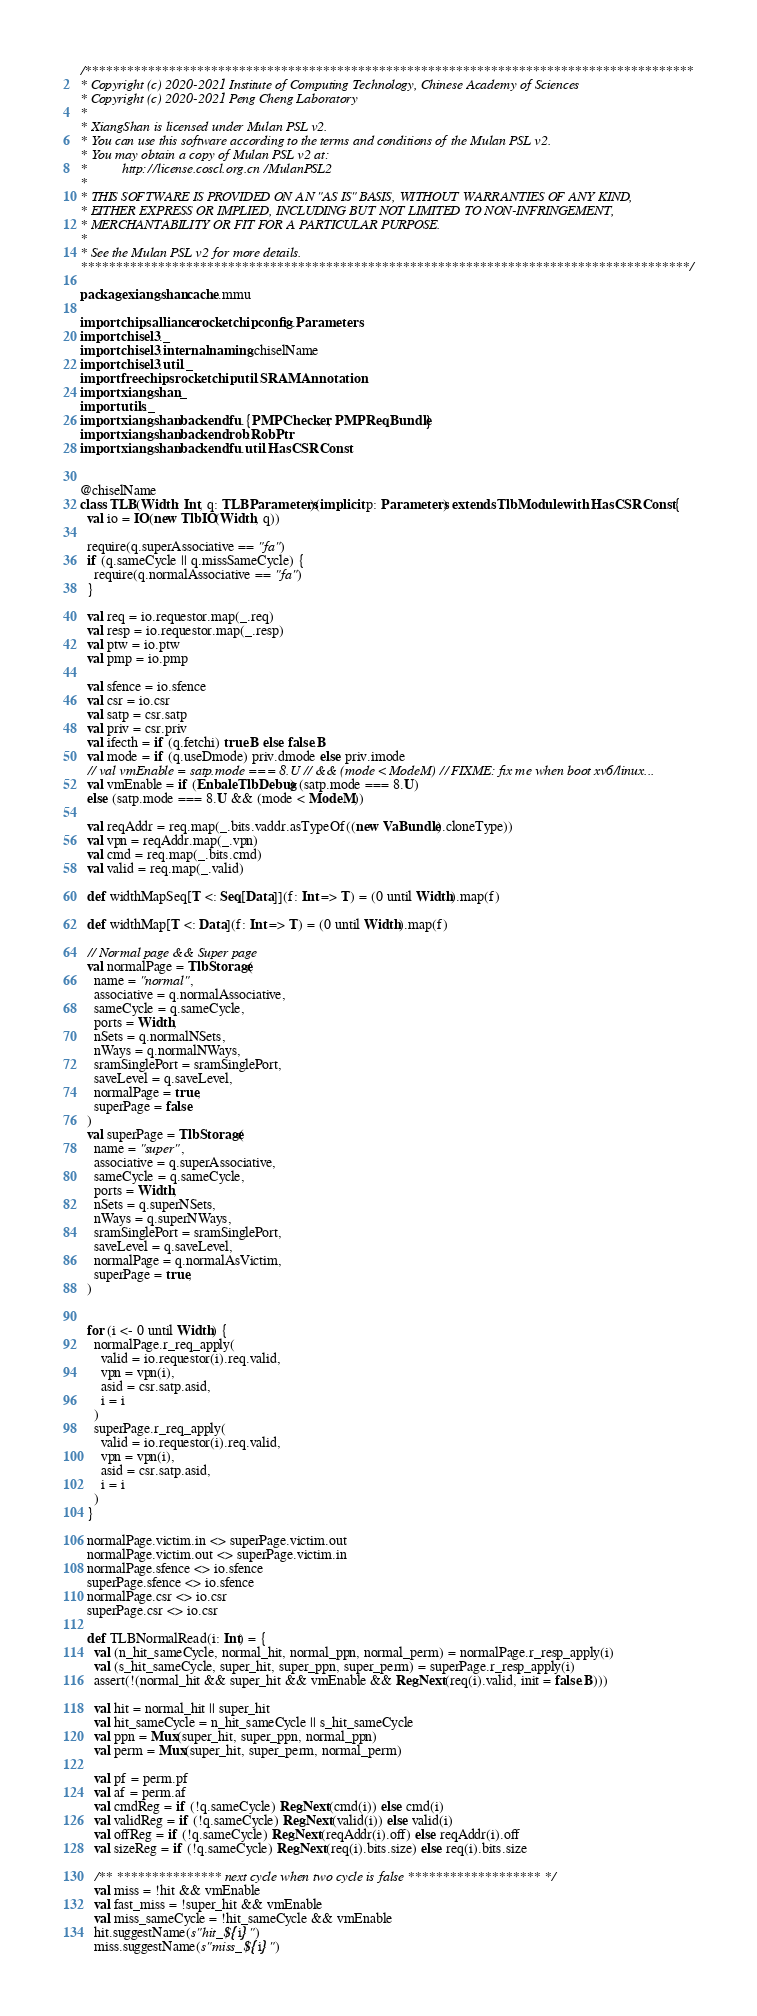Convert code to text. <code><loc_0><loc_0><loc_500><loc_500><_Scala_>/***************************************************************************************
* Copyright (c) 2020-2021 Institute of Computing Technology, Chinese Academy of Sciences
* Copyright (c) 2020-2021 Peng Cheng Laboratory
*
* XiangShan is licensed under Mulan PSL v2.
* You can use this software according to the terms and conditions of the Mulan PSL v2.
* You may obtain a copy of Mulan PSL v2 at:
*          http://license.coscl.org.cn/MulanPSL2
*
* THIS SOFTWARE IS PROVIDED ON AN "AS IS" BASIS, WITHOUT WARRANTIES OF ANY KIND,
* EITHER EXPRESS OR IMPLIED, INCLUDING BUT NOT LIMITED TO NON-INFRINGEMENT,
* MERCHANTABILITY OR FIT FOR A PARTICULAR PURPOSE.
*
* See the Mulan PSL v2 for more details.
***************************************************************************************/

package xiangshan.cache.mmu

import chipsalliance.rocketchip.config.Parameters
import chisel3._
import chisel3.internal.naming.chiselName
import chisel3.util._
import freechips.rocketchip.util.SRAMAnnotation
import xiangshan._
import utils._
import xiangshan.backend.fu.{PMPChecker, PMPReqBundle}
import xiangshan.backend.rob.RobPtr
import xiangshan.backend.fu.util.HasCSRConst


@chiselName
class TLB(Width: Int, q: TLBParameters)(implicit p: Parameters) extends TlbModule with HasCSRConst {
  val io = IO(new TlbIO(Width, q))

  require(q.superAssociative == "fa")
  if (q.sameCycle || q.missSameCycle) {
    require(q.normalAssociative == "fa")
  }

  val req = io.requestor.map(_.req)
  val resp = io.requestor.map(_.resp)
  val ptw = io.ptw
  val pmp = io.pmp

  val sfence = io.sfence
  val csr = io.csr
  val satp = csr.satp
  val priv = csr.priv
  val ifecth = if (q.fetchi) true.B else false.B
  val mode = if (q.useDmode) priv.dmode else priv.imode
  // val vmEnable = satp.mode === 8.U // && (mode < ModeM) // FIXME: fix me when boot xv6/linux...
  val vmEnable = if (EnbaleTlbDebug) (satp.mode === 8.U)
  else (satp.mode === 8.U && (mode < ModeM))

  val reqAddr = req.map(_.bits.vaddr.asTypeOf((new VaBundle).cloneType))
  val vpn = reqAddr.map(_.vpn)
  val cmd = req.map(_.bits.cmd)
  val valid = req.map(_.valid)

  def widthMapSeq[T <: Seq[Data]](f: Int => T) = (0 until Width).map(f)

  def widthMap[T <: Data](f: Int => T) = (0 until Width).map(f)

  // Normal page && Super page
  val normalPage = TlbStorage(
    name = "normal",
    associative = q.normalAssociative,
    sameCycle = q.sameCycle,
    ports = Width,
    nSets = q.normalNSets,
    nWays = q.normalNWays,
    sramSinglePort = sramSinglePort,
    saveLevel = q.saveLevel,
    normalPage = true,
    superPage = false
  )
  val superPage = TlbStorage(
    name = "super",
    associative = q.superAssociative,
    sameCycle = q.sameCycle,
    ports = Width,
    nSets = q.superNSets,
    nWays = q.superNWays,
    sramSinglePort = sramSinglePort,
    saveLevel = q.saveLevel,
    normalPage = q.normalAsVictim,
    superPage = true,
  )


  for (i <- 0 until Width) {
    normalPage.r_req_apply(
      valid = io.requestor(i).req.valid,
      vpn = vpn(i),
      asid = csr.satp.asid,
      i = i
    )
    superPage.r_req_apply(
      valid = io.requestor(i).req.valid,
      vpn = vpn(i),
      asid = csr.satp.asid,
      i = i
    )
  }

  normalPage.victim.in <> superPage.victim.out
  normalPage.victim.out <> superPage.victim.in
  normalPage.sfence <> io.sfence
  superPage.sfence <> io.sfence
  normalPage.csr <> io.csr
  superPage.csr <> io.csr

  def TLBNormalRead(i: Int) = {
    val (n_hit_sameCycle, normal_hit, normal_ppn, normal_perm) = normalPage.r_resp_apply(i)
    val (s_hit_sameCycle, super_hit, super_ppn, super_perm) = superPage.r_resp_apply(i)
    assert(!(normal_hit && super_hit && vmEnable && RegNext(req(i).valid, init = false.B)))

    val hit = normal_hit || super_hit
    val hit_sameCycle = n_hit_sameCycle || s_hit_sameCycle
    val ppn = Mux(super_hit, super_ppn, normal_ppn)
    val perm = Mux(super_hit, super_perm, normal_perm)

    val pf = perm.pf
    val af = perm.af
    val cmdReg = if (!q.sameCycle) RegNext(cmd(i)) else cmd(i)
    val validReg = if (!q.sameCycle) RegNext(valid(i)) else valid(i)
    val offReg = if (!q.sameCycle) RegNext(reqAddr(i).off) else reqAddr(i).off
    val sizeReg = if (!q.sameCycle) RegNext(req(i).bits.size) else req(i).bits.size

    /** *************** next cycle when two cycle is false******************* */
    val miss = !hit && vmEnable
    val fast_miss = !super_hit && vmEnable
    val miss_sameCycle = !hit_sameCycle && vmEnable
    hit.suggestName(s"hit_${i}")
    miss.suggestName(s"miss_${i}")
</code> 